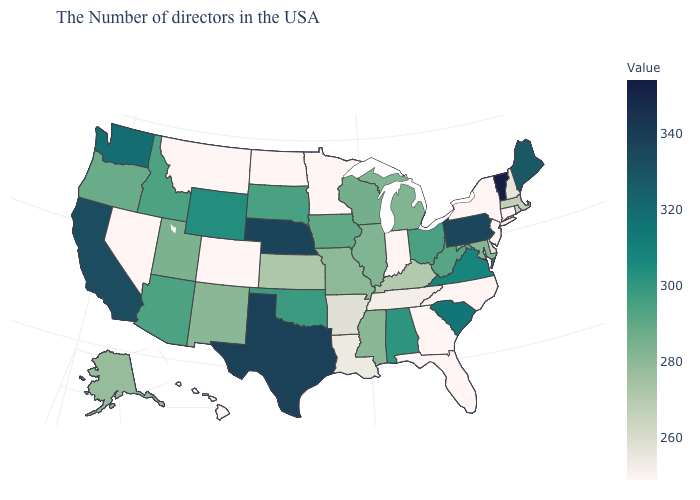Does Utah have the lowest value in the USA?
Short answer required. No. Which states have the lowest value in the USA?
Write a very short answer. Connecticut, New York, New Jersey, North Carolina, Florida, Georgia, Indiana, Minnesota, North Dakota, Colorado, Montana, Nevada, Hawaii. Is the legend a continuous bar?
Give a very brief answer. Yes. Does Maryland have a higher value than Vermont?
Write a very short answer. No. Among the states that border Virginia , which have the highest value?
Be succinct. West Virginia. 